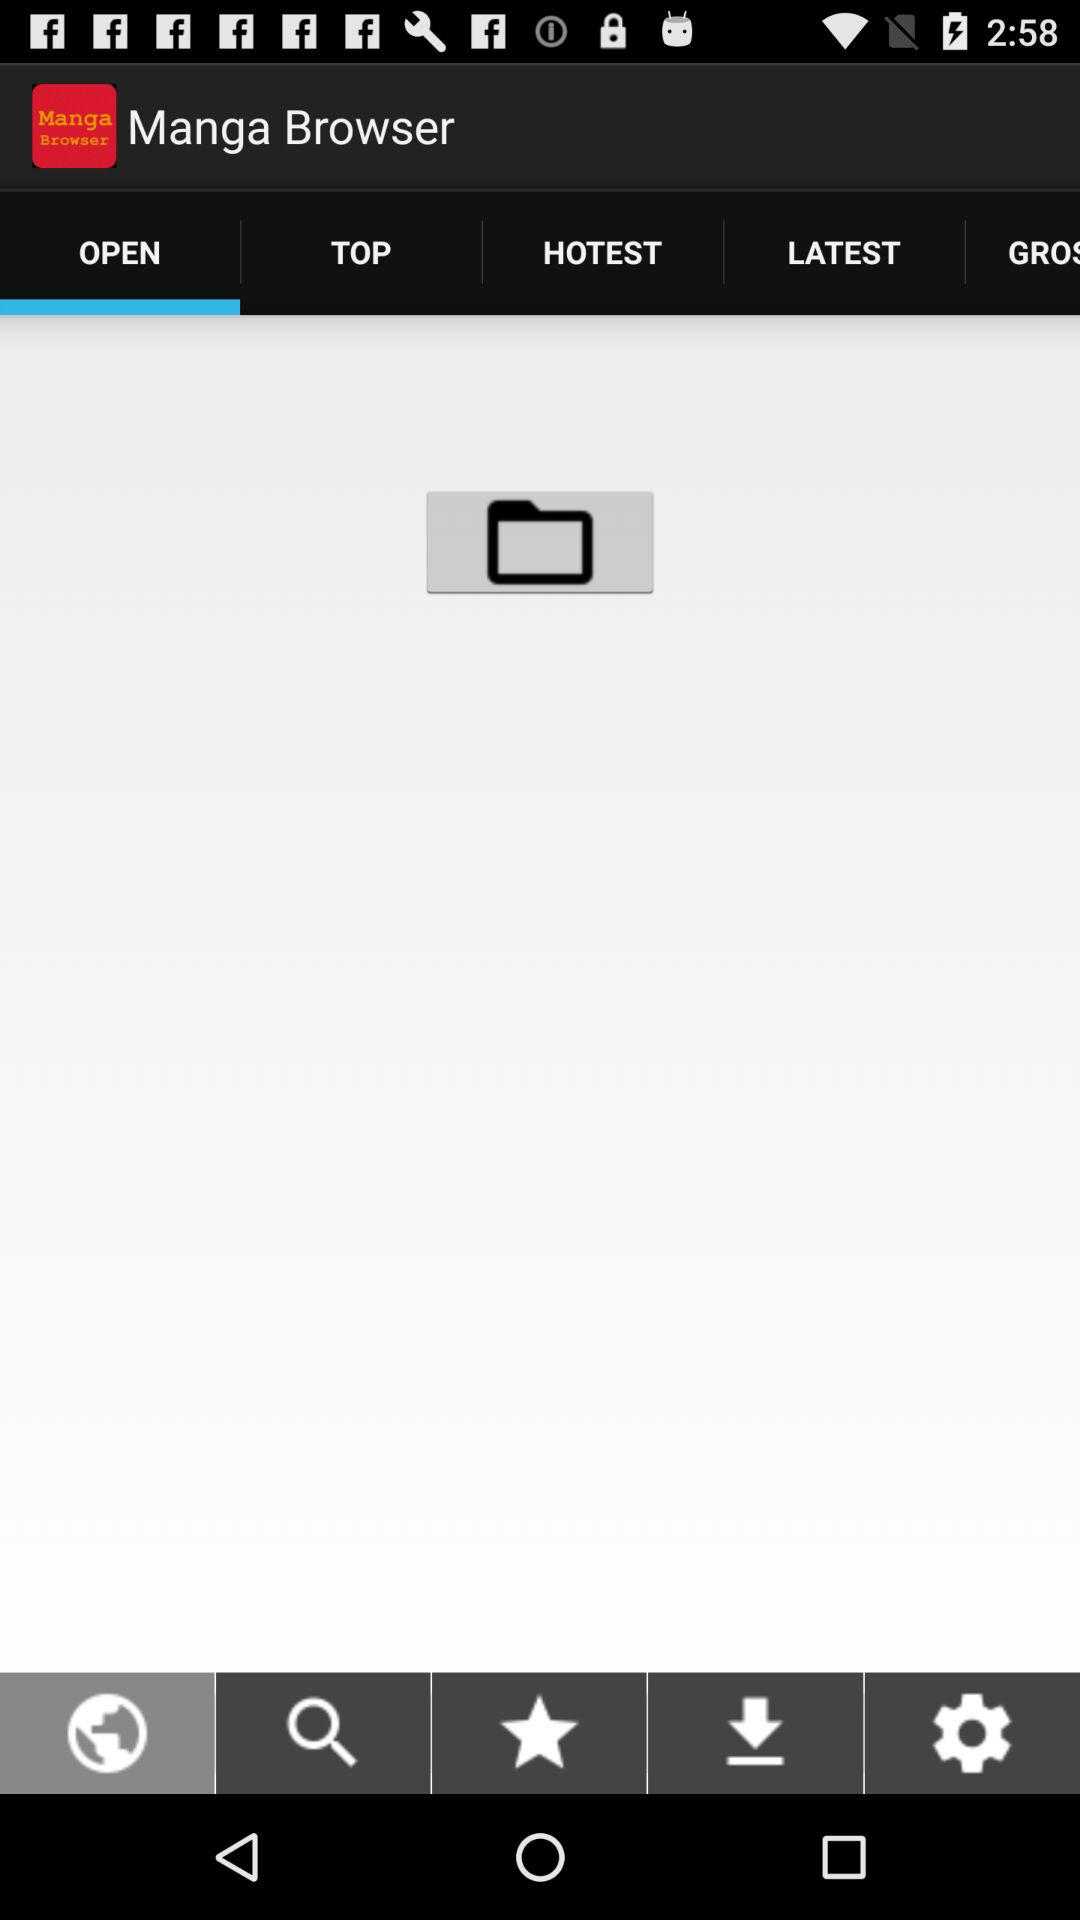What is the application name? The application name is "Manga Browser". 